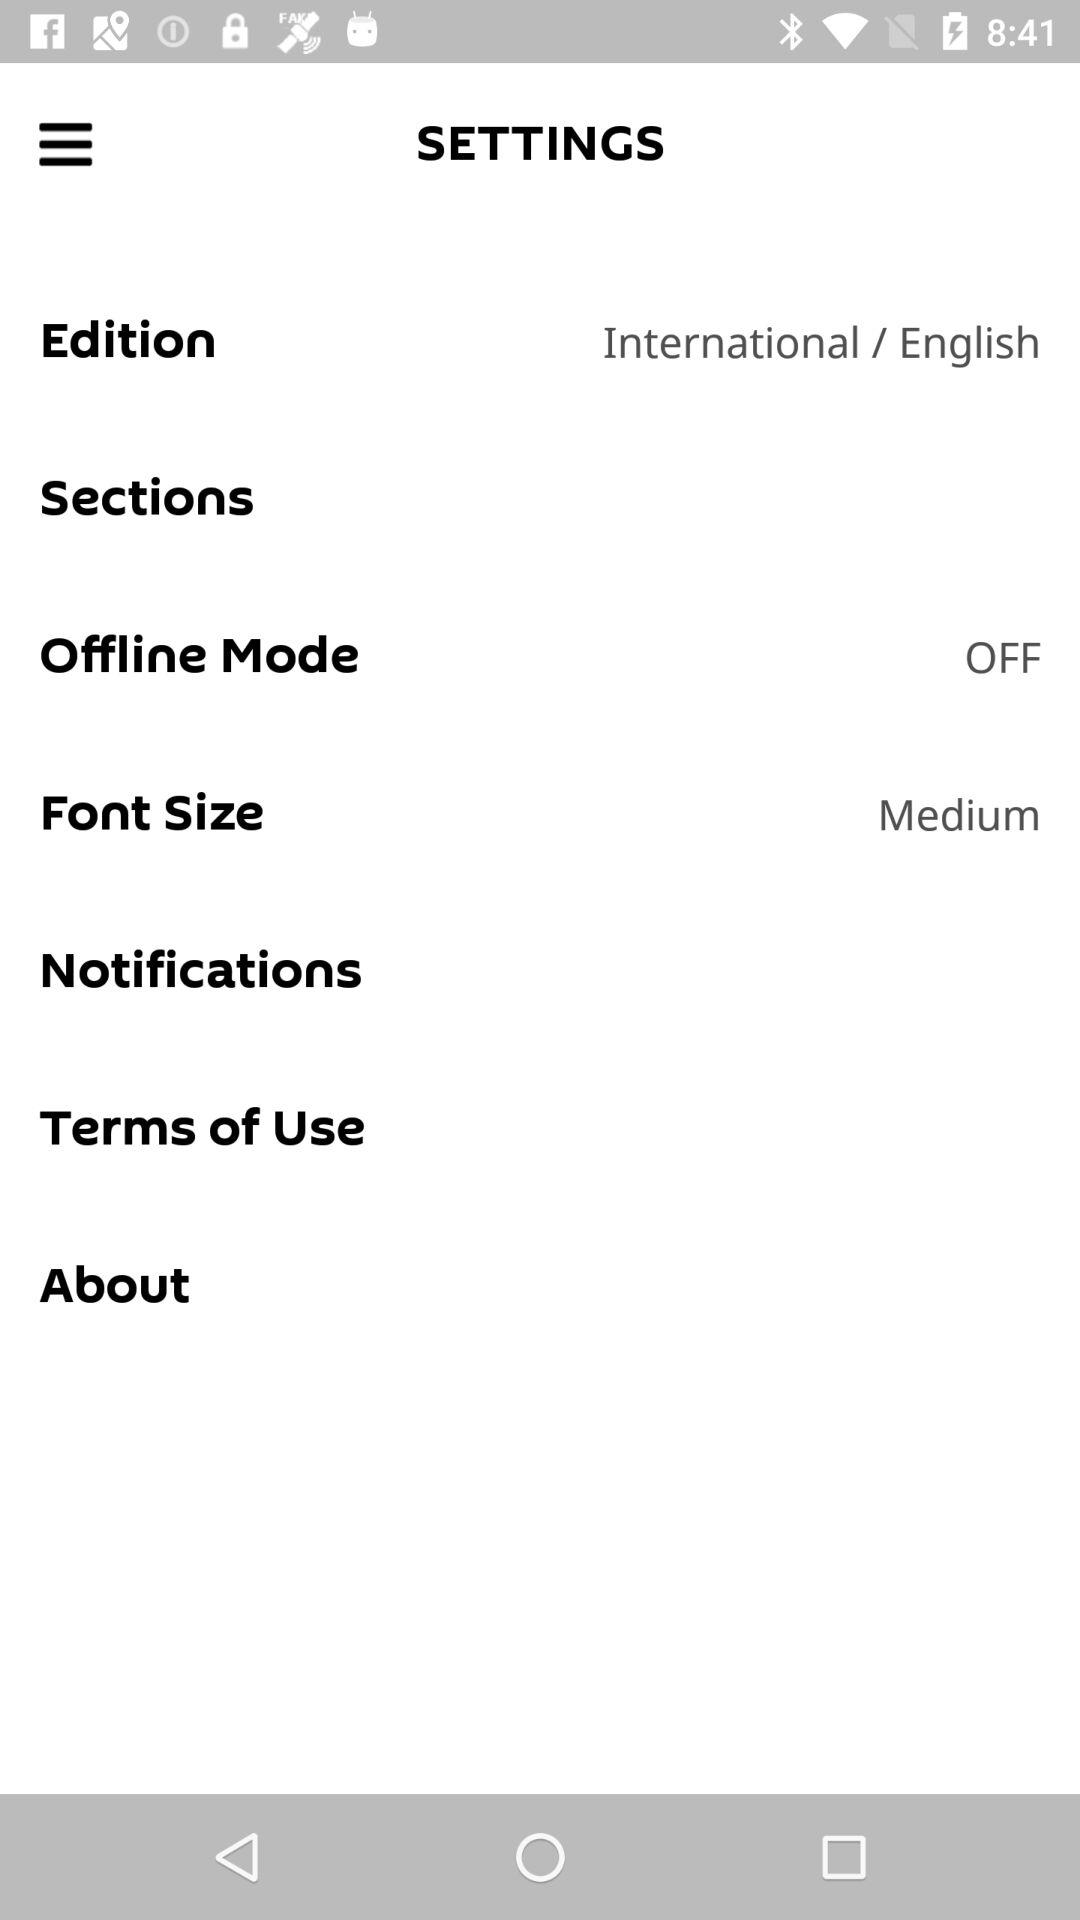What is the selected font size? The selected font size is "Medium". 